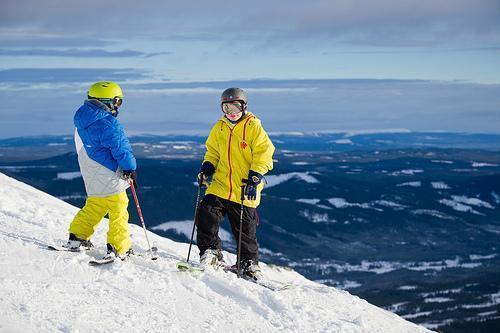How many people are pictured?
Give a very brief answer. 2. 